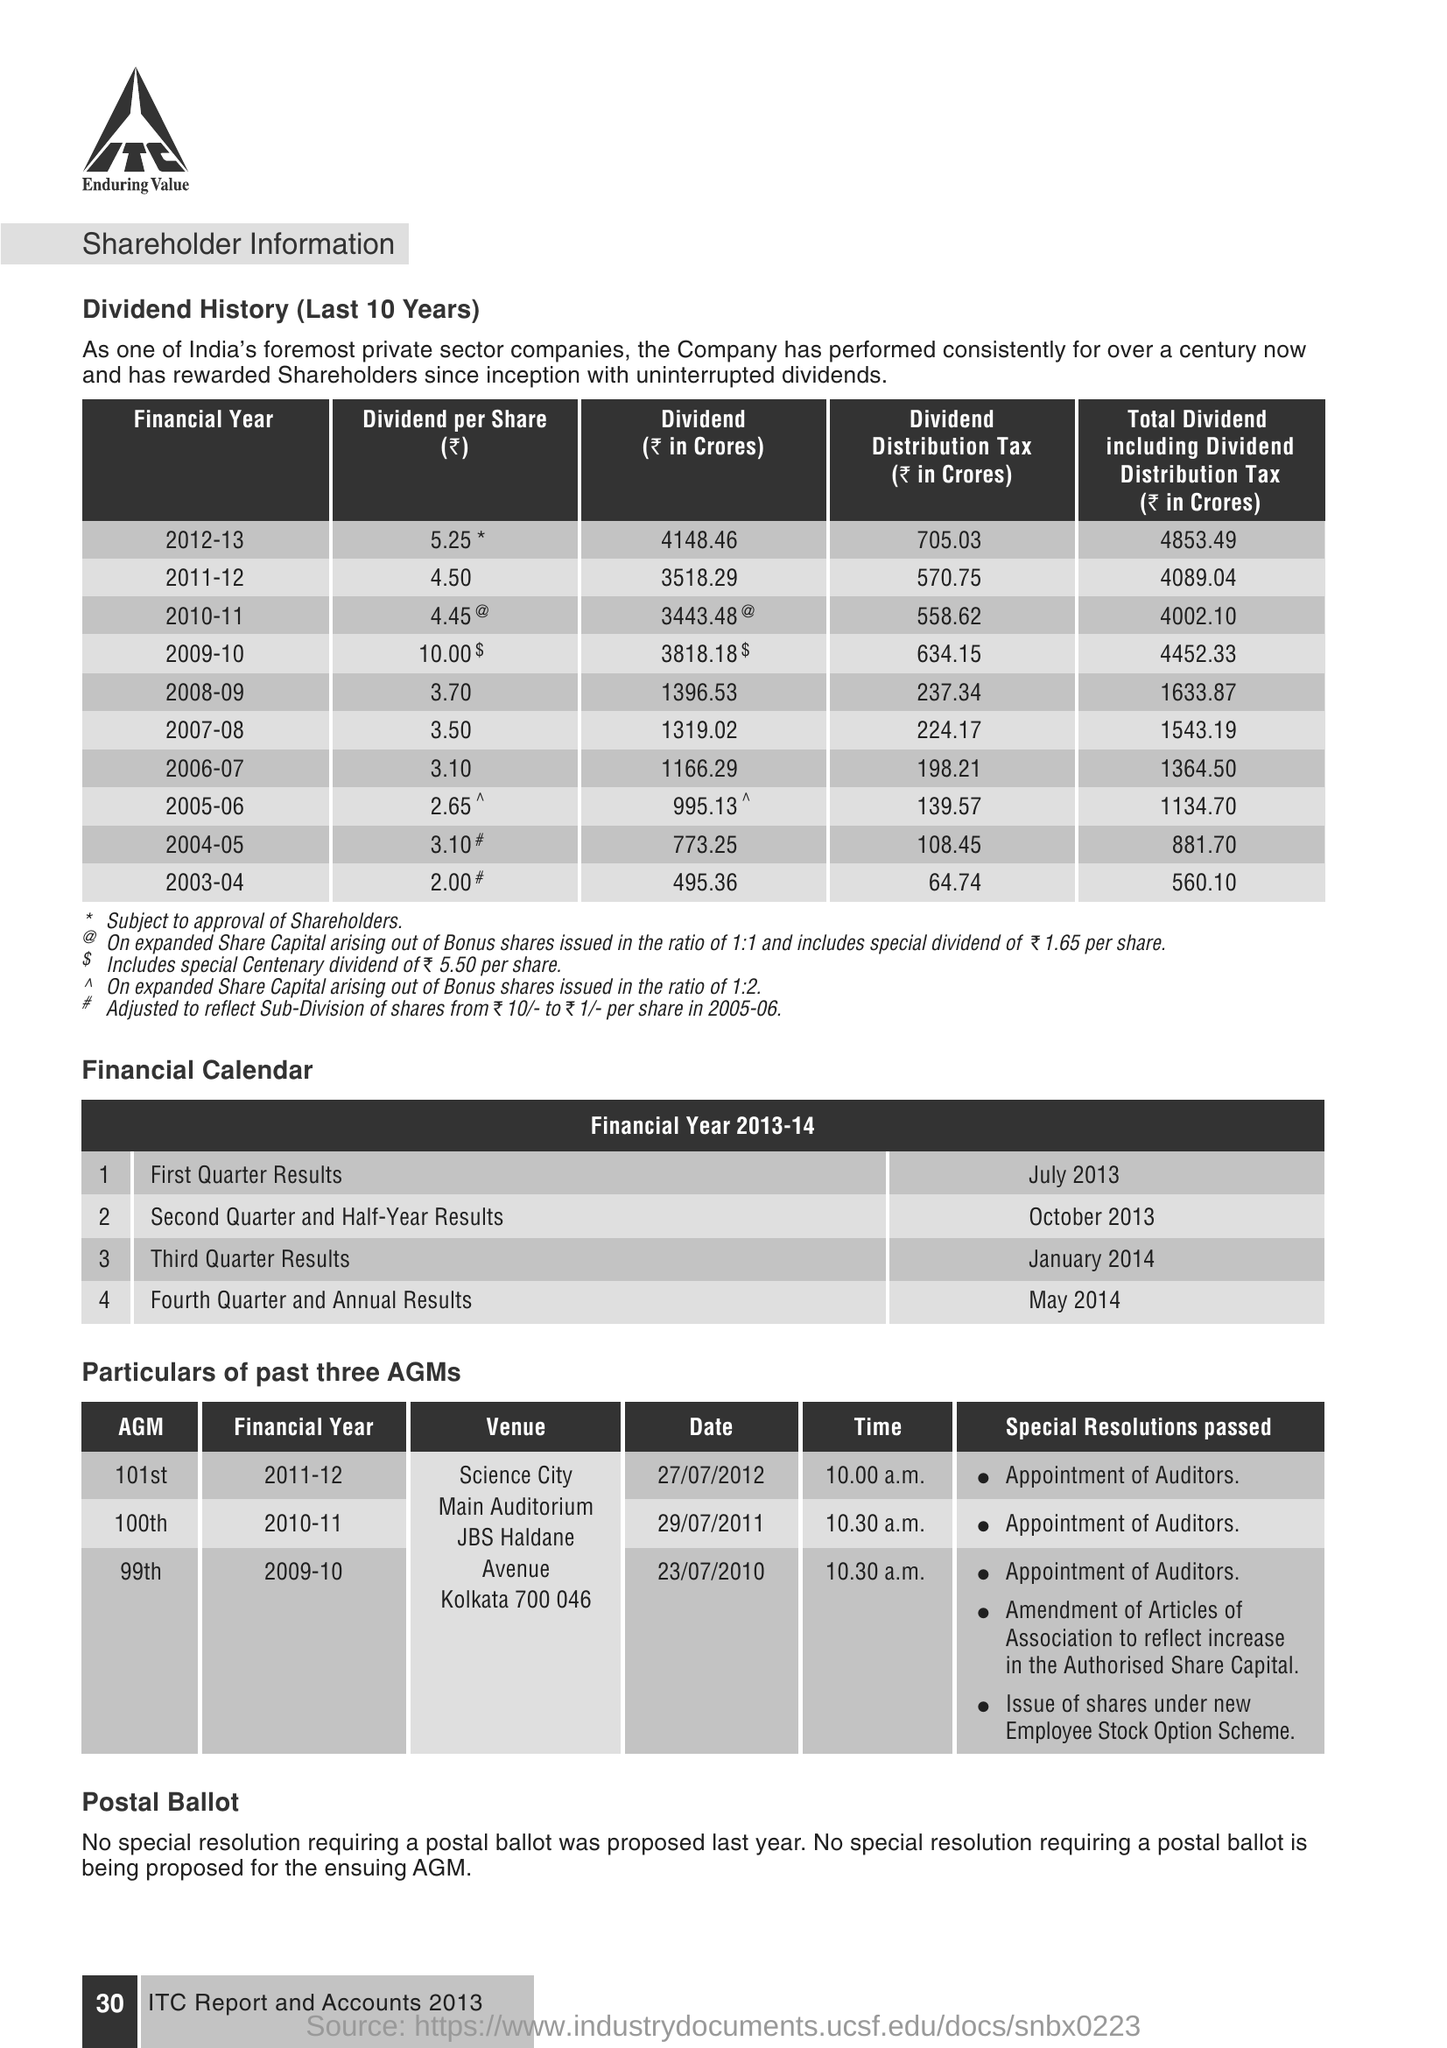on which date the 101st AGM was conducted  ?
 27/07/2012 